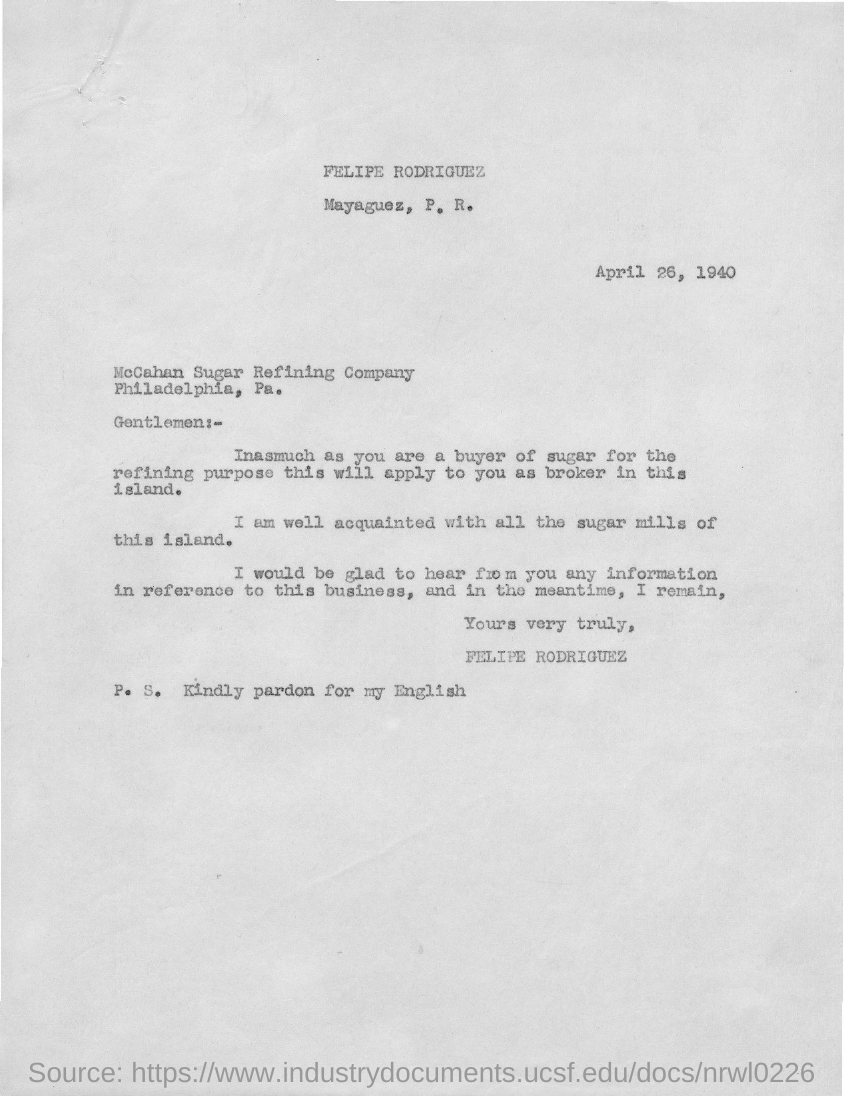Point out several critical features in this image. The date mentioned in this letter is April 26, 1940. 